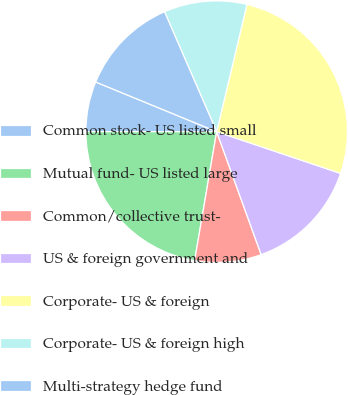Convert chart. <chart><loc_0><loc_0><loc_500><loc_500><pie_chart><fcel>Common stock- US listed small<fcel>Mutual fund- US listed large<fcel>Common/collective trust-<fcel>US & foreign government and<fcel>Corporate- US & foreign<fcel>Corporate- US & foreign high<fcel>Multi-strategy hedge fund<nl><fcel>6.2%<fcel>22.31%<fcel>8.22%<fcel>14.3%<fcel>26.45%<fcel>10.25%<fcel>12.27%<nl></chart> 